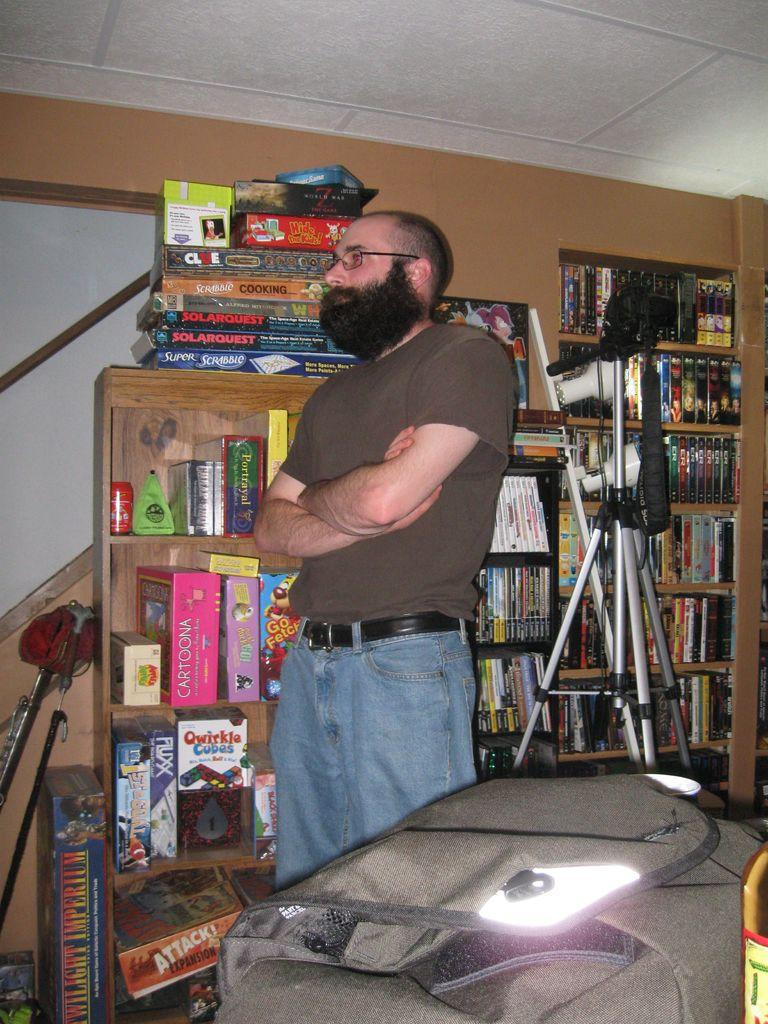Provide a one-sentence caption for the provided image. a man standing in front of a shelf of games with one of them labeled as 'cartoona'. 